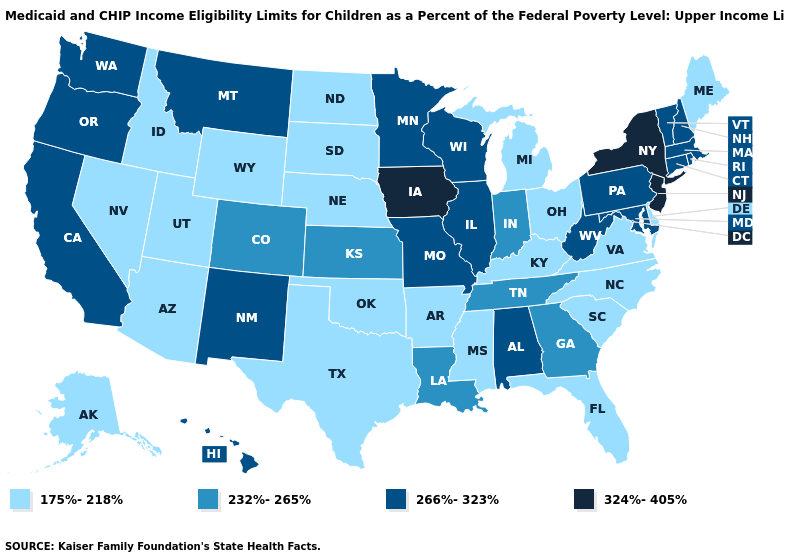Is the legend a continuous bar?
Short answer required. No. Name the states that have a value in the range 232%-265%?
Quick response, please. Colorado, Georgia, Indiana, Kansas, Louisiana, Tennessee. Does the map have missing data?
Answer briefly. No. Which states have the highest value in the USA?
Be succinct. Iowa, New Jersey, New York. Among the states that border New Hampshire , does Massachusetts have the lowest value?
Short answer required. No. Name the states that have a value in the range 175%-218%?
Answer briefly. Alaska, Arizona, Arkansas, Delaware, Florida, Idaho, Kentucky, Maine, Michigan, Mississippi, Nebraska, Nevada, North Carolina, North Dakota, Ohio, Oklahoma, South Carolina, South Dakota, Texas, Utah, Virginia, Wyoming. Which states have the lowest value in the West?
Short answer required. Alaska, Arizona, Idaho, Nevada, Utah, Wyoming. Which states have the lowest value in the South?
Give a very brief answer. Arkansas, Delaware, Florida, Kentucky, Mississippi, North Carolina, Oklahoma, South Carolina, Texas, Virginia. Does Maine have a higher value than New Jersey?
Quick response, please. No. What is the highest value in states that border Mississippi?
Give a very brief answer. 266%-323%. What is the lowest value in the USA?
Quick response, please. 175%-218%. Does Utah have the lowest value in the West?
Give a very brief answer. Yes. What is the value of Idaho?
Quick response, please. 175%-218%. Name the states that have a value in the range 175%-218%?
Answer briefly. Alaska, Arizona, Arkansas, Delaware, Florida, Idaho, Kentucky, Maine, Michigan, Mississippi, Nebraska, Nevada, North Carolina, North Dakota, Ohio, Oklahoma, South Carolina, South Dakota, Texas, Utah, Virginia, Wyoming. Name the states that have a value in the range 324%-405%?
Short answer required. Iowa, New Jersey, New York. 